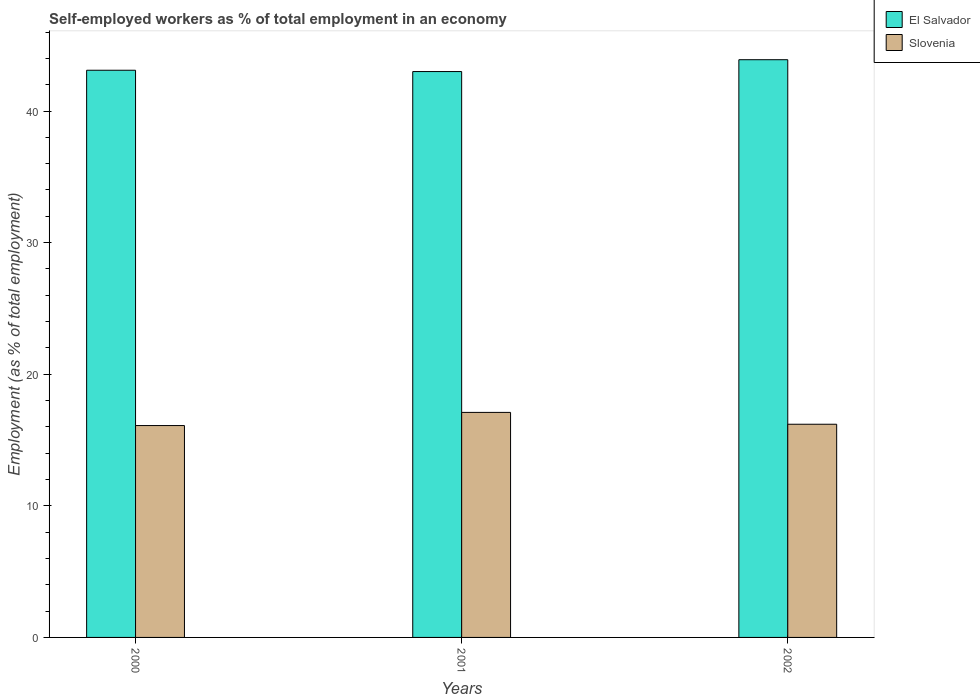How many different coloured bars are there?
Your answer should be very brief. 2. Are the number of bars on each tick of the X-axis equal?
Ensure brevity in your answer.  Yes. How many bars are there on the 1st tick from the left?
Ensure brevity in your answer.  2. How many bars are there on the 2nd tick from the right?
Your answer should be compact. 2. What is the label of the 2nd group of bars from the left?
Give a very brief answer. 2001. What is the percentage of self-employed workers in Slovenia in 2002?
Keep it short and to the point. 16.2. Across all years, what is the maximum percentage of self-employed workers in Slovenia?
Offer a terse response. 17.1. Across all years, what is the minimum percentage of self-employed workers in Slovenia?
Offer a terse response. 16.1. In which year was the percentage of self-employed workers in El Salvador maximum?
Make the answer very short. 2002. What is the total percentage of self-employed workers in El Salvador in the graph?
Ensure brevity in your answer.  130. What is the difference between the percentage of self-employed workers in Slovenia in 2001 and that in 2002?
Make the answer very short. 0.9. What is the difference between the percentage of self-employed workers in Slovenia in 2000 and the percentage of self-employed workers in El Salvador in 2001?
Provide a succinct answer. -26.9. What is the average percentage of self-employed workers in El Salvador per year?
Your response must be concise. 43.33. In the year 2000, what is the difference between the percentage of self-employed workers in El Salvador and percentage of self-employed workers in Slovenia?
Provide a succinct answer. 27. In how many years, is the percentage of self-employed workers in Slovenia greater than 34 %?
Ensure brevity in your answer.  0. What is the ratio of the percentage of self-employed workers in El Salvador in 2001 to that in 2002?
Keep it short and to the point. 0.98. Is the percentage of self-employed workers in El Salvador in 2000 less than that in 2001?
Your answer should be compact. No. What is the difference between the highest and the second highest percentage of self-employed workers in El Salvador?
Ensure brevity in your answer.  0.8. Is the sum of the percentage of self-employed workers in El Salvador in 2000 and 2002 greater than the maximum percentage of self-employed workers in Slovenia across all years?
Give a very brief answer. Yes. What does the 1st bar from the left in 2002 represents?
Keep it short and to the point. El Salvador. What does the 2nd bar from the right in 2001 represents?
Keep it short and to the point. El Salvador. Are all the bars in the graph horizontal?
Offer a very short reply. No. Does the graph contain grids?
Offer a very short reply. No. Where does the legend appear in the graph?
Give a very brief answer. Top right. How many legend labels are there?
Ensure brevity in your answer.  2. How are the legend labels stacked?
Make the answer very short. Vertical. What is the title of the graph?
Keep it short and to the point. Self-employed workers as % of total employment in an economy. What is the label or title of the Y-axis?
Your response must be concise. Employment (as % of total employment). What is the Employment (as % of total employment) of El Salvador in 2000?
Your answer should be very brief. 43.1. What is the Employment (as % of total employment) of Slovenia in 2000?
Keep it short and to the point. 16.1. What is the Employment (as % of total employment) in El Salvador in 2001?
Your response must be concise. 43. What is the Employment (as % of total employment) in Slovenia in 2001?
Your answer should be very brief. 17.1. What is the Employment (as % of total employment) in El Salvador in 2002?
Provide a short and direct response. 43.9. What is the Employment (as % of total employment) in Slovenia in 2002?
Provide a succinct answer. 16.2. Across all years, what is the maximum Employment (as % of total employment) of El Salvador?
Your answer should be very brief. 43.9. Across all years, what is the maximum Employment (as % of total employment) of Slovenia?
Offer a terse response. 17.1. Across all years, what is the minimum Employment (as % of total employment) of Slovenia?
Offer a very short reply. 16.1. What is the total Employment (as % of total employment) in El Salvador in the graph?
Your answer should be very brief. 130. What is the total Employment (as % of total employment) of Slovenia in the graph?
Ensure brevity in your answer.  49.4. What is the difference between the Employment (as % of total employment) in Slovenia in 2000 and that in 2001?
Provide a short and direct response. -1. What is the difference between the Employment (as % of total employment) in El Salvador in 2000 and that in 2002?
Your answer should be very brief. -0.8. What is the difference between the Employment (as % of total employment) in Slovenia in 2000 and that in 2002?
Provide a succinct answer. -0.1. What is the difference between the Employment (as % of total employment) in El Salvador in 2001 and that in 2002?
Keep it short and to the point. -0.9. What is the difference between the Employment (as % of total employment) of Slovenia in 2001 and that in 2002?
Your answer should be compact. 0.9. What is the difference between the Employment (as % of total employment) of El Salvador in 2000 and the Employment (as % of total employment) of Slovenia in 2002?
Your answer should be very brief. 26.9. What is the difference between the Employment (as % of total employment) of El Salvador in 2001 and the Employment (as % of total employment) of Slovenia in 2002?
Make the answer very short. 26.8. What is the average Employment (as % of total employment) in El Salvador per year?
Your answer should be very brief. 43.33. What is the average Employment (as % of total employment) of Slovenia per year?
Offer a very short reply. 16.47. In the year 2001, what is the difference between the Employment (as % of total employment) in El Salvador and Employment (as % of total employment) in Slovenia?
Your answer should be compact. 25.9. In the year 2002, what is the difference between the Employment (as % of total employment) of El Salvador and Employment (as % of total employment) of Slovenia?
Make the answer very short. 27.7. What is the ratio of the Employment (as % of total employment) of Slovenia in 2000 to that in 2001?
Provide a succinct answer. 0.94. What is the ratio of the Employment (as % of total employment) in El Salvador in 2000 to that in 2002?
Offer a terse response. 0.98. What is the ratio of the Employment (as % of total employment) of Slovenia in 2000 to that in 2002?
Your response must be concise. 0.99. What is the ratio of the Employment (as % of total employment) of El Salvador in 2001 to that in 2002?
Give a very brief answer. 0.98. What is the ratio of the Employment (as % of total employment) in Slovenia in 2001 to that in 2002?
Keep it short and to the point. 1.06. What is the difference between the highest and the lowest Employment (as % of total employment) of El Salvador?
Your answer should be compact. 0.9. 